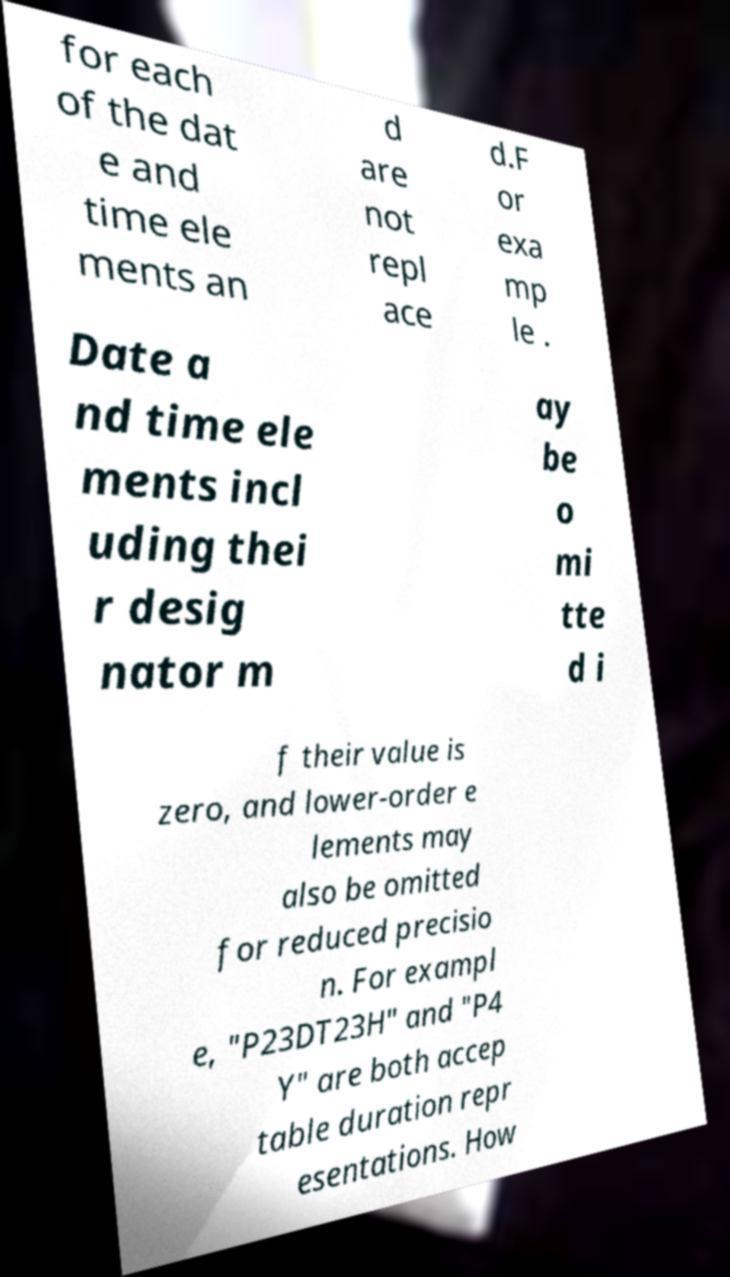For documentation purposes, I need the text within this image transcribed. Could you provide that? for each of the dat e and time ele ments an d are not repl ace d.F or exa mp le . Date a nd time ele ments incl uding thei r desig nator m ay be o mi tte d i f their value is zero, and lower-order e lements may also be omitted for reduced precisio n. For exampl e, "P23DT23H" and "P4 Y" are both accep table duration repr esentations. How 